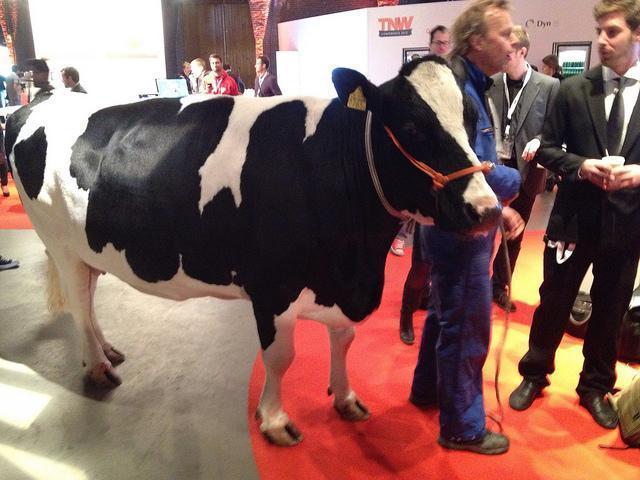How many people can be seen?
Give a very brief answer. 3. How many cows are in the picture?
Give a very brief answer. 1. 